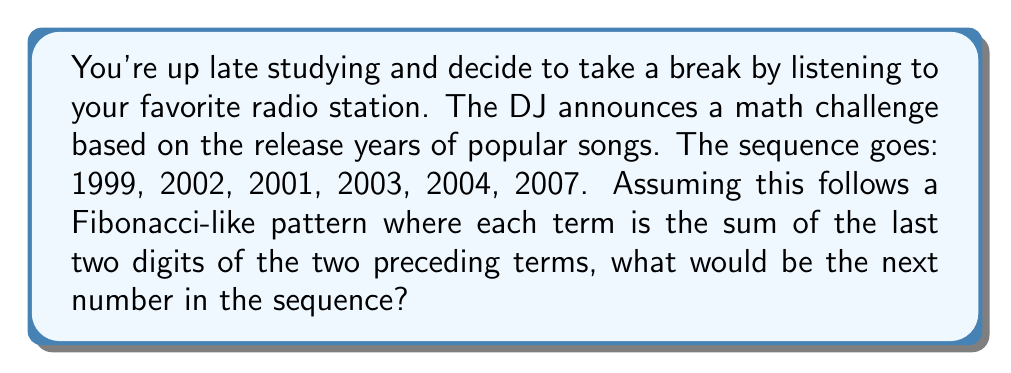Help me with this question. Let's break this down step-by-step:

1) First, let's look at the given sequence:
   1999, 2002, 2001, 2003, 2004, 2007

2) We're told that each term is the sum of the last two digits of the two preceding terms. Let's verify this:

   - 2001: Last two digits of 1999 (99) + Last two digits of 2002 (02) = 99 + 02 = 101, so we take 01
   - 2003: Last two digits of 2002 (02) + Last two digits of 2001 (01) = 02 + 01 = 03
   - 2004: Last two digits of 2001 (01) + Last two digits of 2003 (03) = 01 + 03 = 04
   - 2007: Last two digits of 2003 (03) + Last two digits of 2004 (04) = 03 + 04 = 07

3) To find the next term, we need to sum the last two digits of the two preceding terms:

   Last two digits of 2004 (04) + Last two digits of 2007 (07) = 04 + 07 = 11

4) Therefore, the next term in the sequence would be 2011.

This sequence is Fibonacci-like because each term depends on the two preceding terms, but instead of summing the full numbers, we're only summing their last two digits.
Answer: 2011 